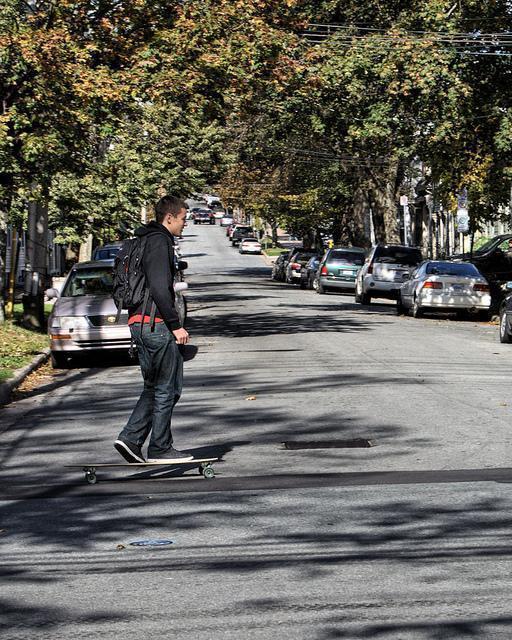What country does the white car originate from?
Select the accurate answer and provide explanation: 'Answer: answer
Rationale: rationale.'
Options: Israel, america, japan, canada. Answer: japan.
Rationale: The car comes from japan. 